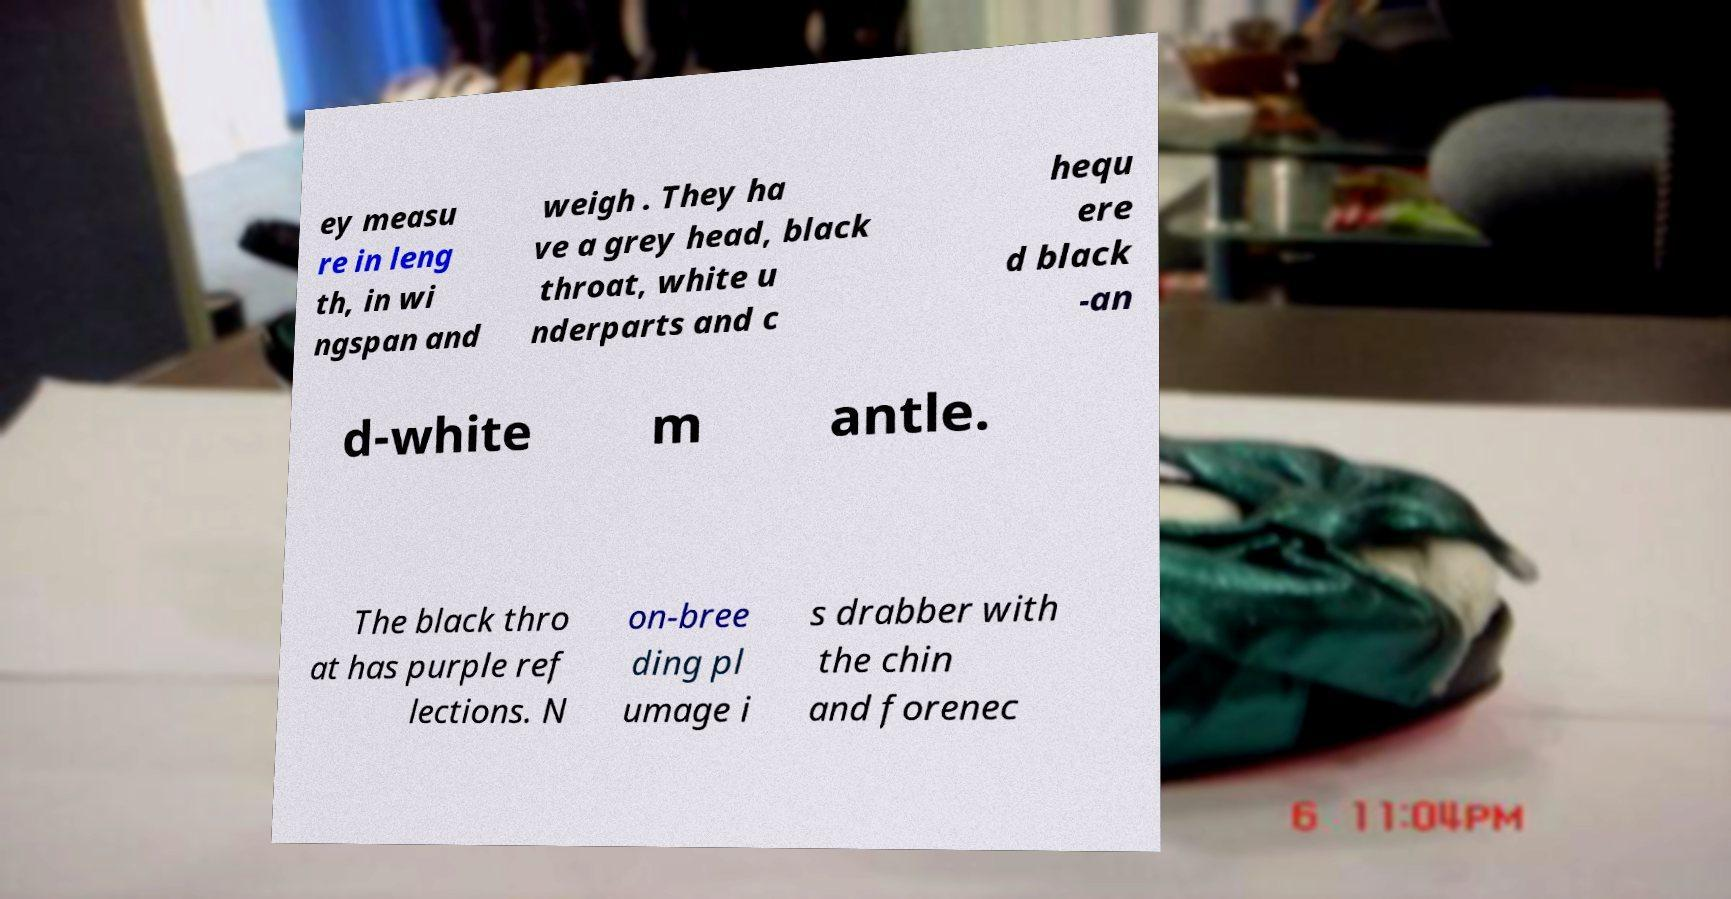I need the written content from this picture converted into text. Can you do that? ey measu re in leng th, in wi ngspan and weigh . They ha ve a grey head, black throat, white u nderparts and c hequ ere d black -an d-white m antle. The black thro at has purple ref lections. N on-bree ding pl umage i s drabber with the chin and forenec 